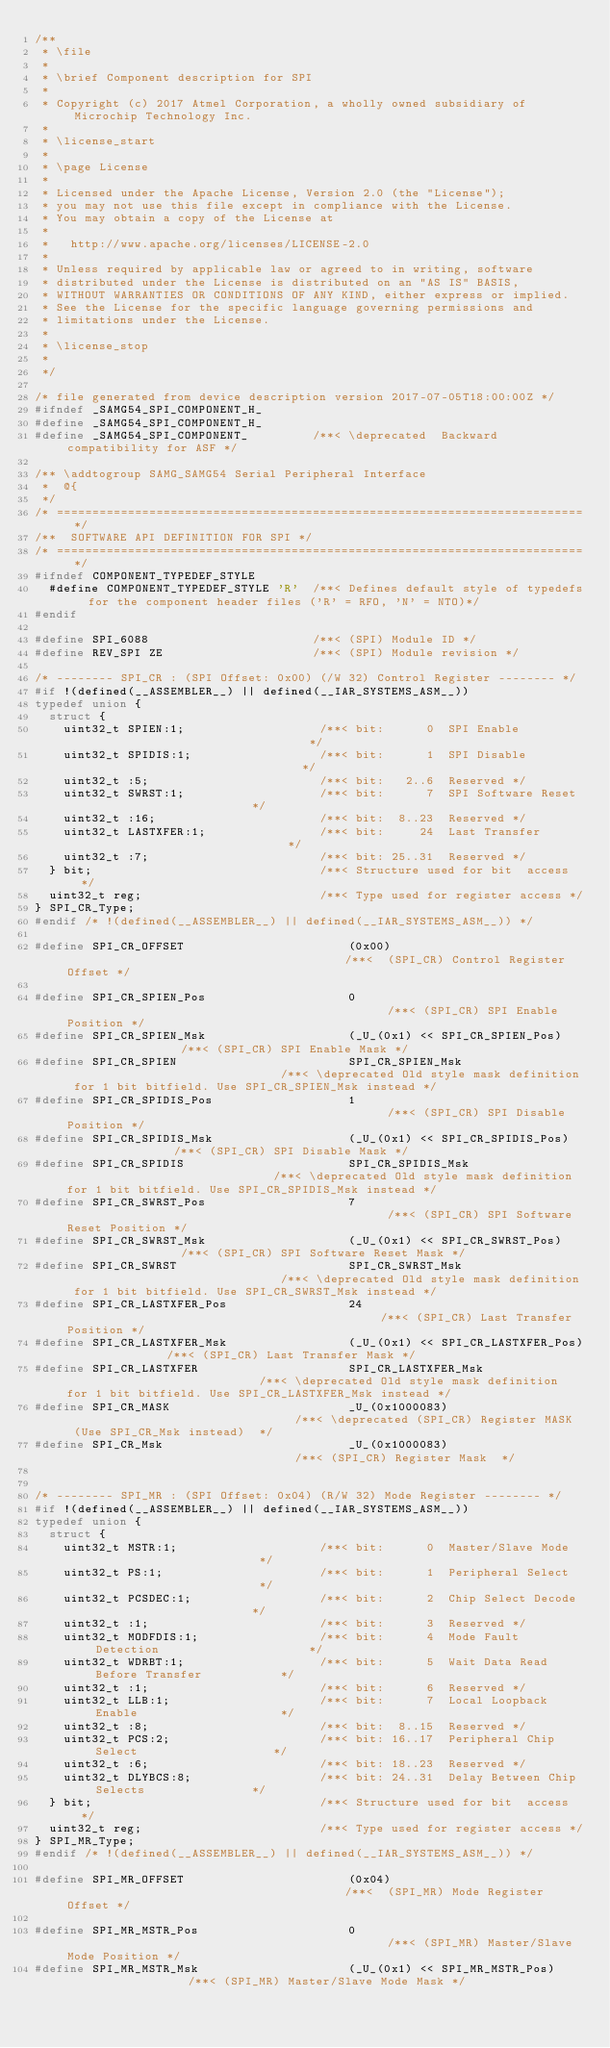Convert code to text. <code><loc_0><loc_0><loc_500><loc_500><_C_>/**
 * \file
 *
 * \brief Component description for SPI
 *
 * Copyright (c) 2017 Atmel Corporation, a wholly owned subsidiary of Microchip Technology Inc.
 *
 * \license_start
 *
 * \page License
 *
 * Licensed under the Apache License, Version 2.0 (the "License");
 * you may not use this file except in compliance with the License.
 * You may obtain a copy of the License at
 *
 *   http://www.apache.org/licenses/LICENSE-2.0
 *
 * Unless required by applicable law or agreed to in writing, software
 * distributed under the License is distributed on an "AS IS" BASIS,
 * WITHOUT WARRANTIES OR CONDITIONS OF ANY KIND, either express or implied.
 * See the License for the specific language governing permissions and
 * limitations under the License.
 *
 * \license_stop
 *
 */

/* file generated from device description version 2017-07-05T18:00:00Z */
#ifndef _SAMG54_SPI_COMPONENT_H_
#define _SAMG54_SPI_COMPONENT_H_
#define _SAMG54_SPI_COMPONENT_         /**< \deprecated  Backward compatibility for ASF */

/** \addtogroup SAMG_SAMG54 Serial Peripheral Interface
 *  @{
 */
/* ========================================================================== */
/**  SOFTWARE API DEFINITION FOR SPI */
/* ========================================================================== */
#ifndef COMPONENT_TYPEDEF_STYLE
  #define COMPONENT_TYPEDEF_STYLE 'R'  /**< Defines default style of typedefs for the component header files ('R' = RFO, 'N' = NTO)*/
#endif

#define SPI_6088                       /**< (SPI) Module ID */
#define REV_SPI ZE                     /**< (SPI) Module revision */

/* -------- SPI_CR : (SPI Offset: 0x00) (/W 32) Control Register -------- */
#if !(defined(__ASSEMBLER__) || defined(__IAR_SYSTEMS_ASM__))
typedef union { 
  struct {
    uint32_t SPIEN:1;                   /**< bit:      0  SPI Enable                               */
    uint32_t SPIDIS:1;                  /**< bit:      1  SPI Disable                              */
    uint32_t :5;                        /**< bit:   2..6  Reserved */
    uint32_t SWRST:1;                   /**< bit:      7  SPI Software Reset                       */
    uint32_t :16;                       /**< bit:  8..23  Reserved */
    uint32_t LASTXFER:1;                /**< bit:     24  Last Transfer                            */
    uint32_t :7;                        /**< bit: 25..31  Reserved */
  } bit;                                /**< Structure used for bit  access */
  uint32_t reg;                         /**< Type used for register access */
} SPI_CR_Type;
#endif /* !(defined(__ASSEMBLER__) || defined(__IAR_SYSTEMS_ASM__)) */

#define SPI_CR_OFFSET                       (0x00)                                        /**<  (SPI_CR) Control Register  Offset */

#define SPI_CR_SPIEN_Pos                    0                                              /**< (SPI_CR) SPI Enable Position */
#define SPI_CR_SPIEN_Msk                    (_U_(0x1) << SPI_CR_SPIEN_Pos)                 /**< (SPI_CR) SPI Enable Mask */
#define SPI_CR_SPIEN                        SPI_CR_SPIEN_Msk                               /**< \deprecated Old style mask definition for 1 bit bitfield. Use SPI_CR_SPIEN_Msk instead */
#define SPI_CR_SPIDIS_Pos                   1                                              /**< (SPI_CR) SPI Disable Position */
#define SPI_CR_SPIDIS_Msk                   (_U_(0x1) << SPI_CR_SPIDIS_Pos)                /**< (SPI_CR) SPI Disable Mask */
#define SPI_CR_SPIDIS                       SPI_CR_SPIDIS_Msk                              /**< \deprecated Old style mask definition for 1 bit bitfield. Use SPI_CR_SPIDIS_Msk instead */
#define SPI_CR_SWRST_Pos                    7                                              /**< (SPI_CR) SPI Software Reset Position */
#define SPI_CR_SWRST_Msk                    (_U_(0x1) << SPI_CR_SWRST_Pos)                 /**< (SPI_CR) SPI Software Reset Mask */
#define SPI_CR_SWRST                        SPI_CR_SWRST_Msk                               /**< \deprecated Old style mask definition for 1 bit bitfield. Use SPI_CR_SWRST_Msk instead */
#define SPI_CR_LASTXFER_Pos                 24                                             /**< (SPI_CR) Last Transfer Position */
#define SPI_CR_LASTXFER_Msk                 (_U_(0x1) << SPI_CR_LASTXFER_Pos)              /**< (SPI_CR) Last Transfer Mask */
#define SPI_CR_LASTXFER                     SPI_CR_LASTXFER_Msk                            /**< \deprecated Old style mask definition for 1 bit bitfield. Use SPI_CR_LASTXFER_Msk instead */
#define SPI_CR_MASK                         _U_(0x1000083)                                 /**< \deprecated (SPI_CR) Register MASK  (Use SPI_CR_Msk instead)  */
#define SPI_CR_Msk                          _U_(0x1000083)                                 /**< (SPI_CR) Register Mask  */


/* -------- SPI_MR : (SPI Offset: 0x04) (R/W 32) Mode Register -------- */
#if !(defined(__ASSEMBLER__) || defined(__IAR_SYSTEMS_ASM__))
typedef union { 
  struct {
    uint32_t MSTR:1;                    /**< bit:      0  Master/Slave Mode                        */
    uint32_t PS:1;                      /**< bit:      1  Peripheral Select                        */
    uint32_t PCSDEC:1;                  /**< bit:      2  Chip Select Decode                       */
    uint32_t :1;                        /**< bit:      3  Reserved */
    uint32_t MODFDIS:1;                 /**< bit:      4  Mode Fault Detection                     */
    uint32_t WDRBT:1;                   /**< bit:      5  Wait Data Read Before Transfer           */
    uint32_t :1;                        /**< bit:      6  Reserved */
    uint32_t LLB:1;                     /**< bit:      7  Local Loopback Enable                    */
    uint32_t :8;                        /**< bit:  8..15  Reserved */
    uint32_t PCS:2;                     /**< bit: 16..17  Peripheral Chip Select                   */
    uint32_t :6;                        /**< bit: 18..23  Reserved */
    uint32_t DLYBCS:8;                  /**< bit: 24..31  Delay Between Chip Selects               */
  } bit;                                /**< Structure used for bit  access */
  uint32_t reg;                         /**< Type used for register access */
} SPI_MR_Type;
#endif /* !(defined(__ASSEMBLER__) || defined(__IAR_SYSTEMS_ASM__)) */

#define SPI_MR_OFFSET                       (0x04)                                        /**<  (SPI_MR) Mode Register  Offset */

#define SPI_MR_MSTR_Pos                     0                                              /**< (SPI_MR) Master/Slave Mode Position */
#define SPI_MR_MSTR_Msk                     (_U_(0x1) << SPI_MR_MSTR_Pos)                  /**< (SPI_MR) Master/Slave Mode Mask */</code> 